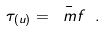<formula> <loc_0><loc_0><loc_500><loc_500>\tau _ { ( u ) } = \bar { \ m f } \ .</formula> 